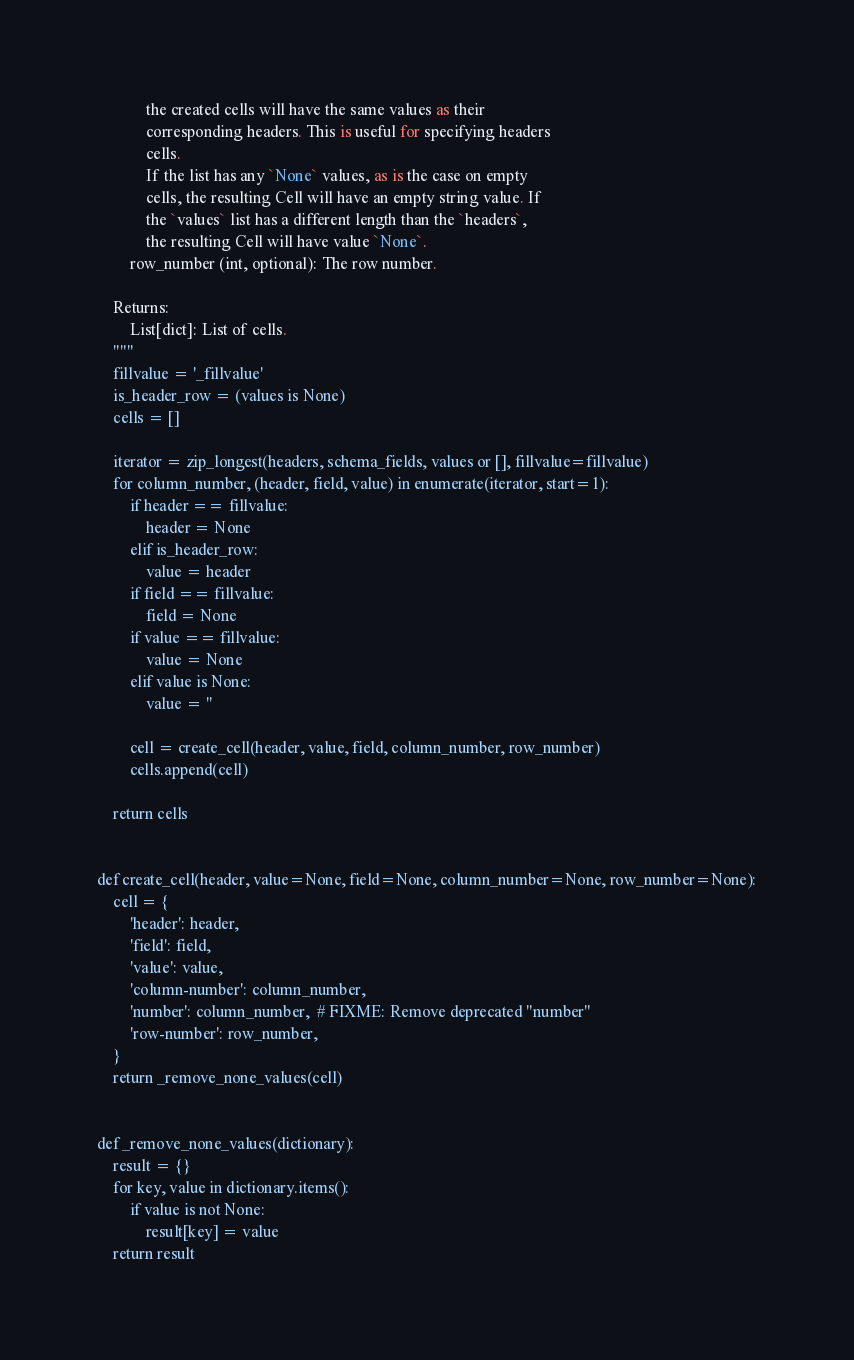<code> <loc_0><loc_0><loc_500><loc_500><_Python_>            the created cells will have the same values as their
            corresponding headers. This is useful for specifying headers
            cells.
            If the list has any `None` values, as is the case on empty
            cells, the resulting Cell will have an empty string value. If
            the `values` list has a different length than the `headers`,
            the resulting Cell will have value `None`.
        row_number (int, optional): The row number.

    Returns:
        List[dict]: List of cells.
    """
    fillvalue = '_fillvalue'
    is_header_row = (values is None)
    cells = []

    iterator = zip_longest(headers, schema_fields, values or [], fillvalue=fillvalue)
    for column_number, (header, field, value) in enumerate(iterator, start=1):
        if header == fillvalue:
            header = None
        elif is_header_row:
            value = header
        if field == fillvalue:
            field = None
        if value == fillvalue:
            value = None
        elif value is None:
            value = ''

        cell = create_cell(header, value, field, column_number, row_number)
        cells.append(cell)

    return cells


def create_cell(header, value=None, field=None, column_number=None, row_number=None):
    cell = {
        'header': header,
        'field': field,
        'value': value,
        'column-number': column_number,
        'number': column_number,  # FIXME: Remove deprecated "number"
        'row-number': row_number,
    }
    return _remove_none_values(cell)


def _remove_none_values(dictionary):
    result = {}
    for key, value in dictionary.items():
        if value is not None:
            result[key] = value
    return result
</code> 